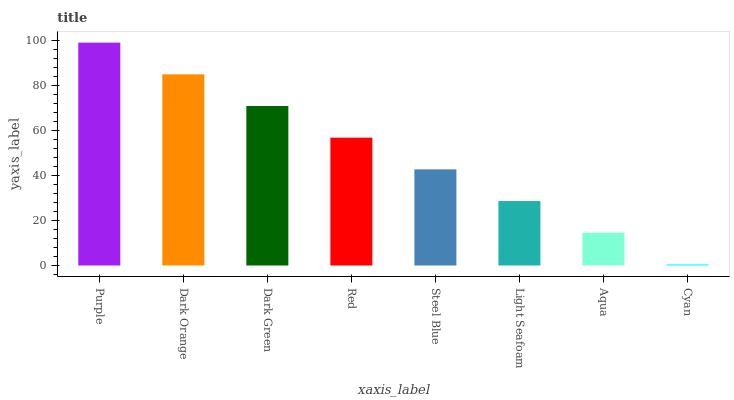Is Cyan the minimum?
Answer yes or no. Yes. Is Purple the maximum?
Answer yes or no. Yes. Is Dark Orange the minimum?
Answer yes or no. No. Is Dark Orange the maximum?
Answer yes or no. No. Is Purple greater than Dark Orange?
Answer yes or no. Yes. Is Dark Orange less than Purple?
Answer yes or no. Yes. Is Dark Orange greater than Purple?
Answer yes or no. No. Is Purple less than Dark Orange?
Answer yes or no. No. Is Red the high median?
Answer yes or no. Yes. Is Steel Blue the low median?
Answer yes or no. Yes. Is Purple the high median?
Answer yes or no. No. Is Aqua the low median?
Answer yes or no. No. 